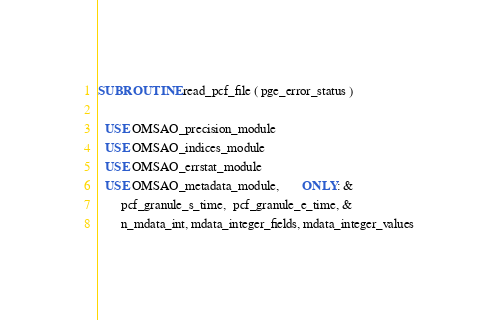<code> <loc_0><loc_0><loc_500><loc_500><_FORTRAN_>SUBROUTINE read_pcf_file ( pge_error_status )

  USE OMSAO_precision_module
  USE OMSAO_indices_module
  USE OMSAO_errstat_module
  USE OMSAO_metadata_module,       ONLY: &
       pcf_granule_s_time,  pcf_granule_e_time, &
       n_mdata_int, mdata_integer_fields, mdata_integer_values</code> 